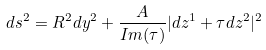<formula> <loc_0><loc_0><loc_500><loc_500>d s ^ { 2 } = R ^ { 2 } d y ^ { 2 } + \frac { A } { I m ( \tau ) } | d z ^ { 1 } + \tau d z ^ { 2 } | ^ { 2 }</formula> 